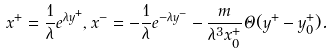<formula> <loc_0><loc_0><loc_500><loc_500>x ^ { + } = \frac { 1 } { \lambda } e ^ { \lambda y ^ { + } } , x ^ { - } = - \frac { 1 } { \lambda } e ^ { - \lambda y ^ { - } } - \frac { m } { \lambda ^ { 3 } x ^ { + } _ { 0 } } \Theta ( y ^ { + } - y ^ { + } _ { 0 } ) .</formula> 